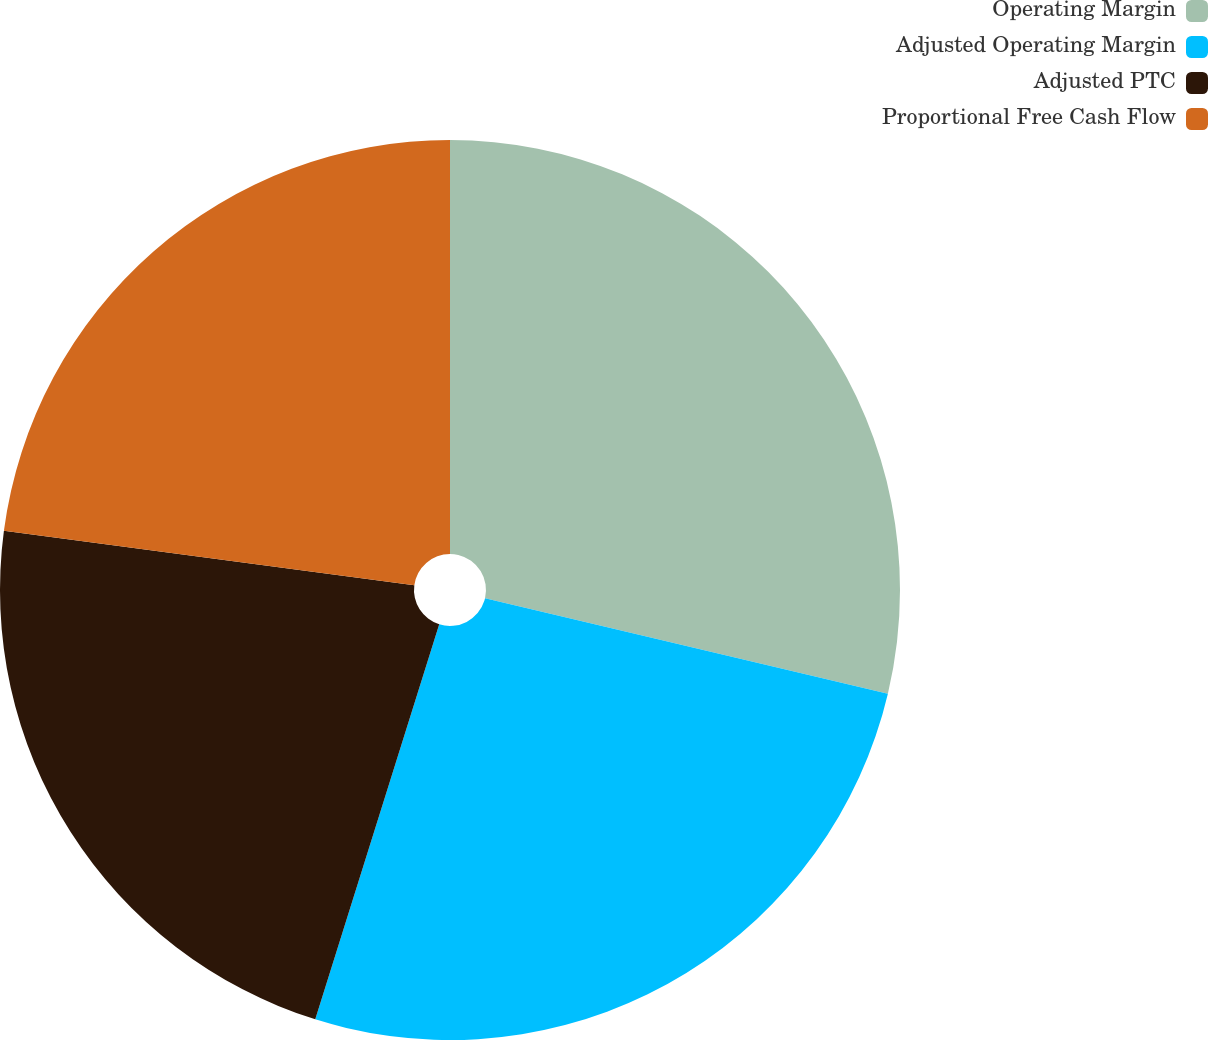Convert chart to OTSL. <chart><loc_0><loc_0><loc_500><loc_500><pie_chart><fcel>Operating Margin<fcel>Adjusted Operating Margin<fcel>Adjusted PTC<fcel>Proportional Free Cash Flow<nl><fcel>28.7%<fcel>26.14%<fcel>22.26%<fcel>22.9%<nl></chart> 